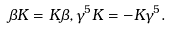Convert formula to latex. <formula><loc_0><loc_0><loc_500><loc_500>\beta K = K \beta , \gamma ^ { 5 } K = - K \gamma ^ { 5 } .</formula> 